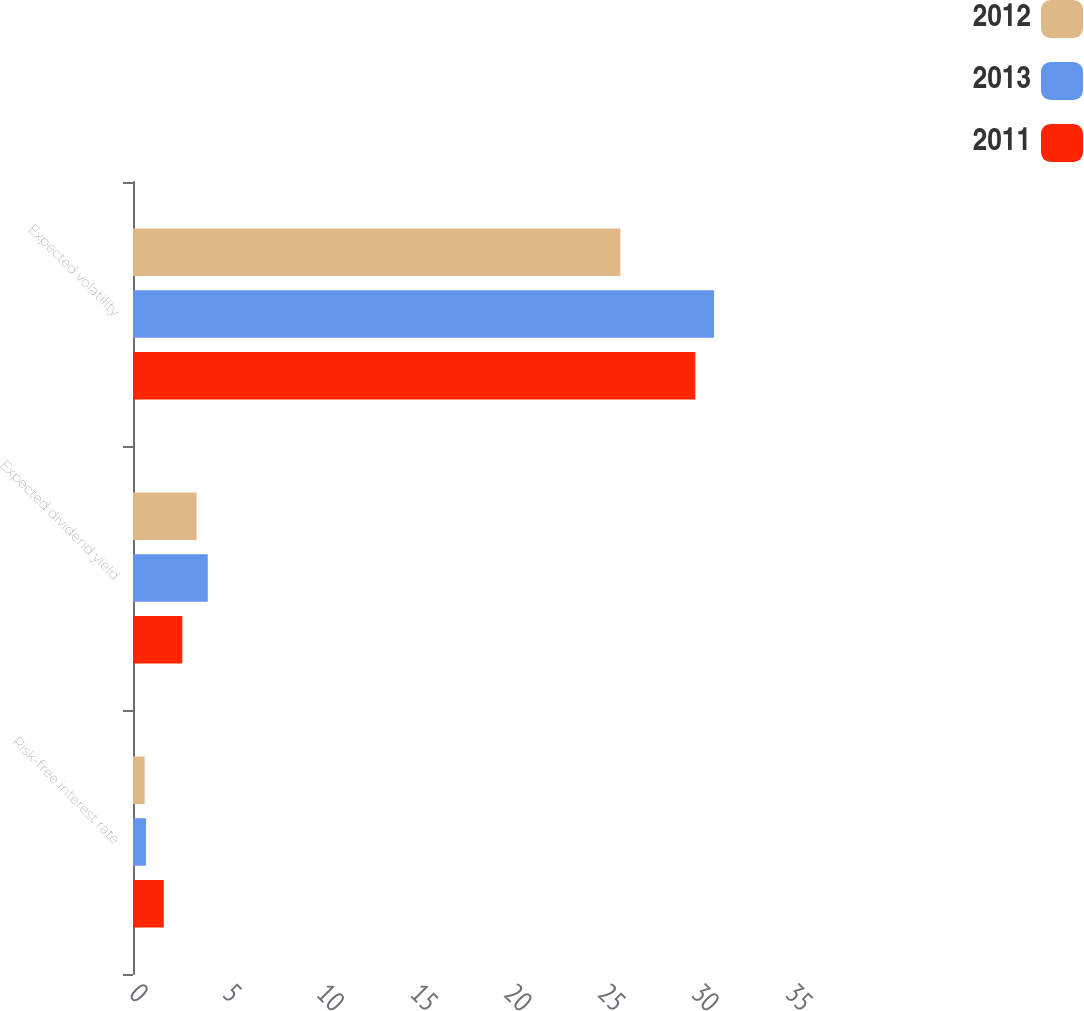Convert chart to OTSL. <chart><loc_0><loc_0><loc_500><loc_500><stacked_bar_chart><ecel><fcel>Risk-free interest rate<fcel>Expected dividend yield<fcel>Expected volatility<nl><fcel>2012<fcel>0.62<fcel>3.39<fcel>26<nl><fcel>2013<fcel>0.69<fcel>3.99<fcel>31<nl><fcel>2011<fcel>1.64<fcel>2.63<fcel>30<nl></chart> 